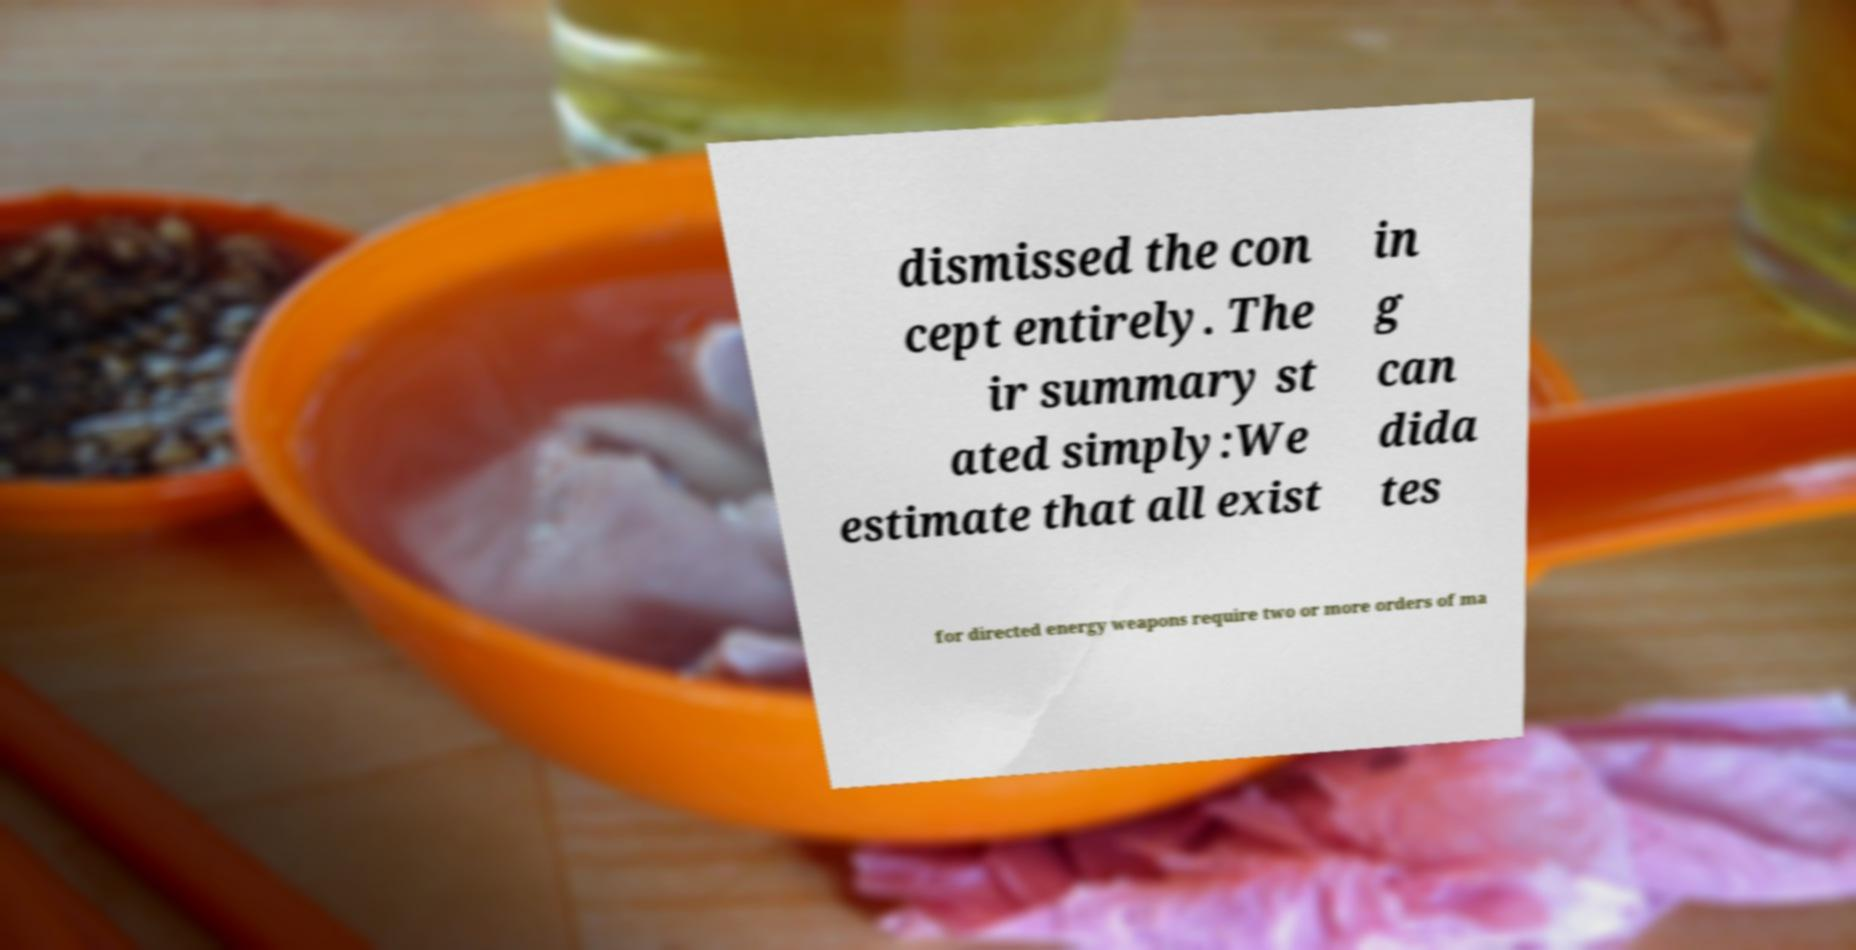For documentation purposes, I need the text within this image transcribed. Could you provide that? dismissed the con cept entirely. The ir summary st ated simply:We estimate that all exist in g can dida tes for directed energy weapons require two or more orders of ma 